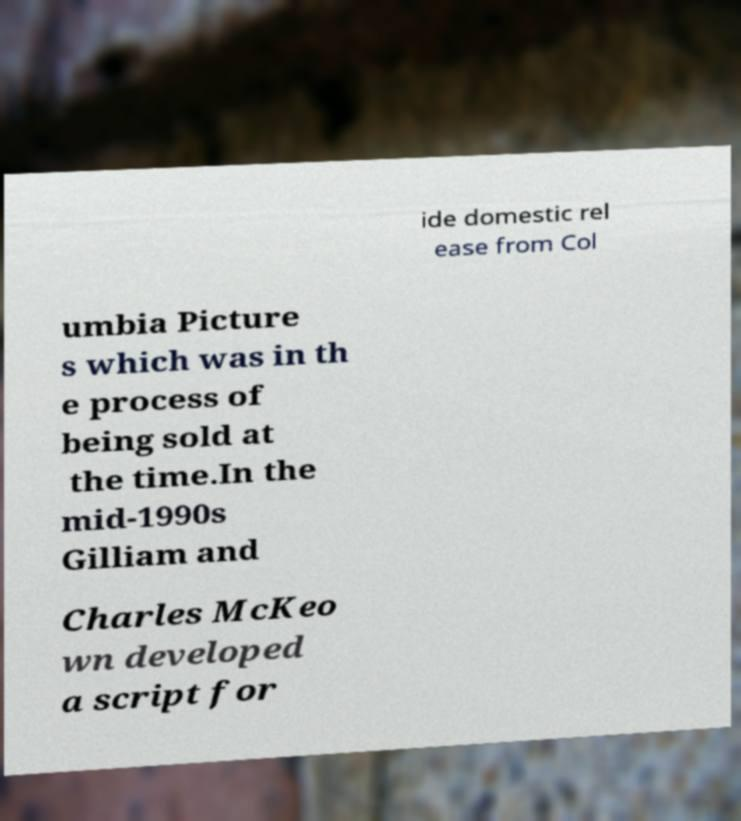Can you accurately transcribe the text from the provided image for me? ide domestic rel ease from Col umbia Picture s which was in th e process of being sold at the time.In the mid-1990s Gilliam and Charles McKeo wn developed a script for 